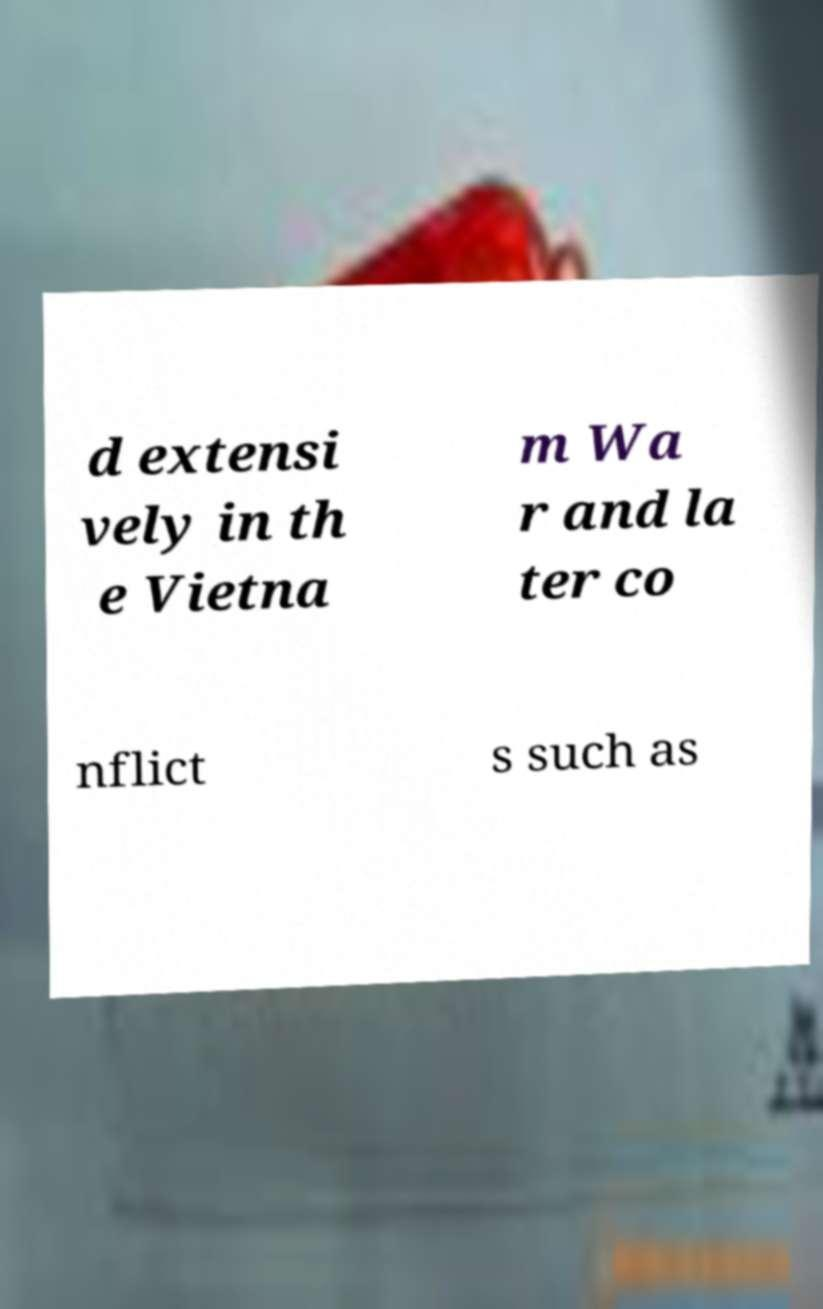Can you accurately transcribe the text from the provided image for me? d extensi vely in th e Vietna m Wa r and la ter co nflict s such as 